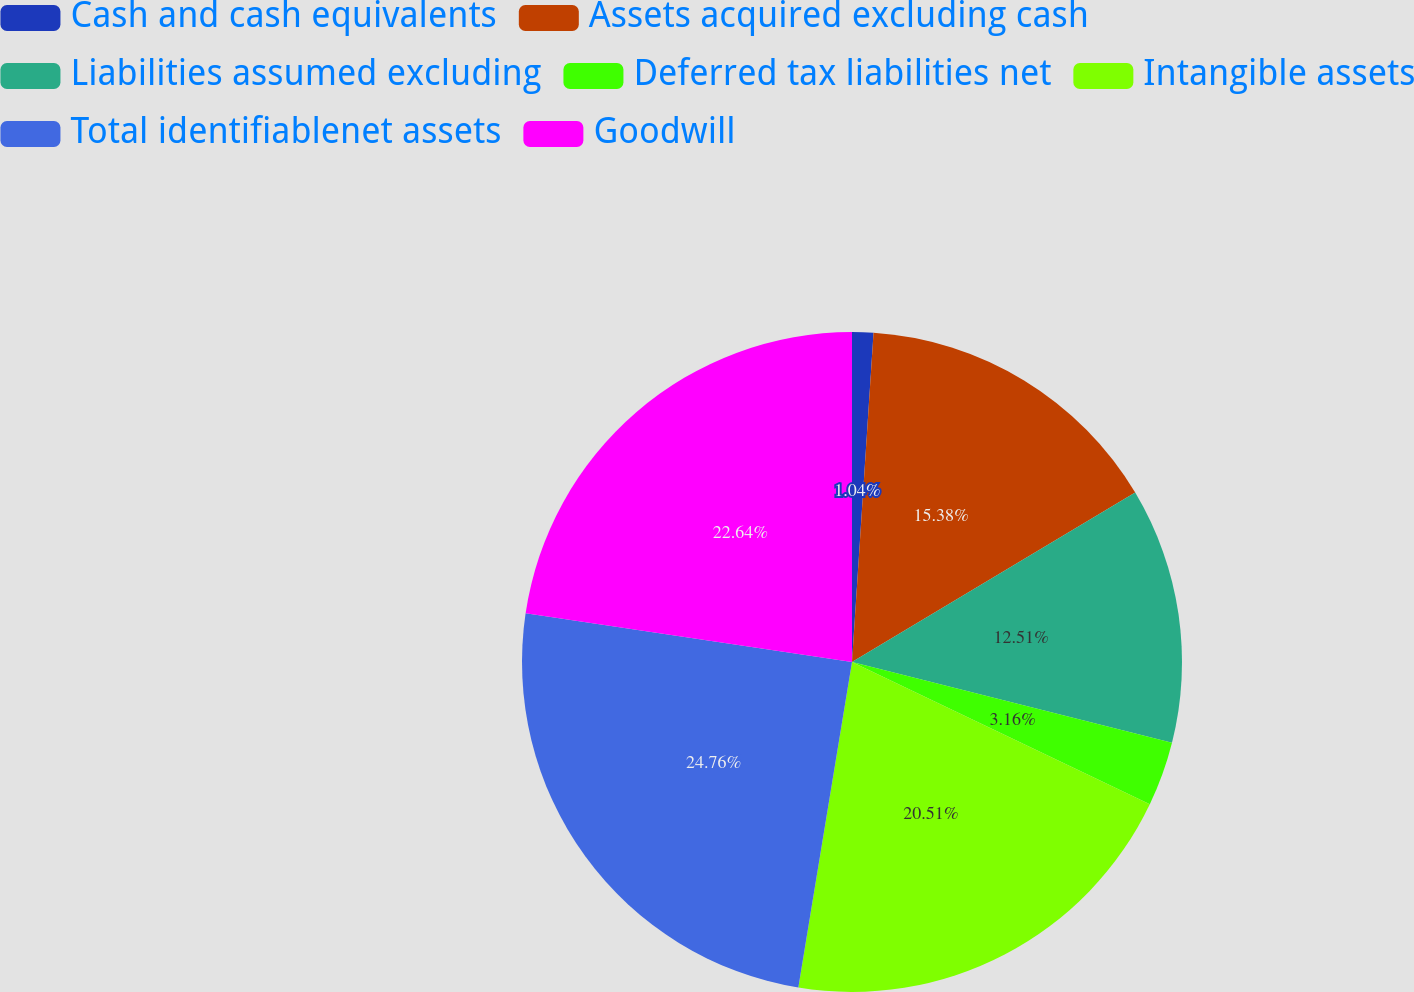Convert chart to OTSL. <chart><loc_0><loc_0><loc_500><loc_500><pie_chart><fcel>Cash and cash equivalents<fcel>Assets acquired excluding cash<fcel>Liabilities assumed excluding<fcel>Deferred tax liabilities net<fcel>Intangible assets<fcel>Total identifiablenet assets<fcel>Goodwill<nl><fcel>1.04%<fcel>15.38%<fcel>12.51%<fcel>3.16%<fcel>20.51%<fcel>24.76%<fcel>22.64%<nl></chart> 